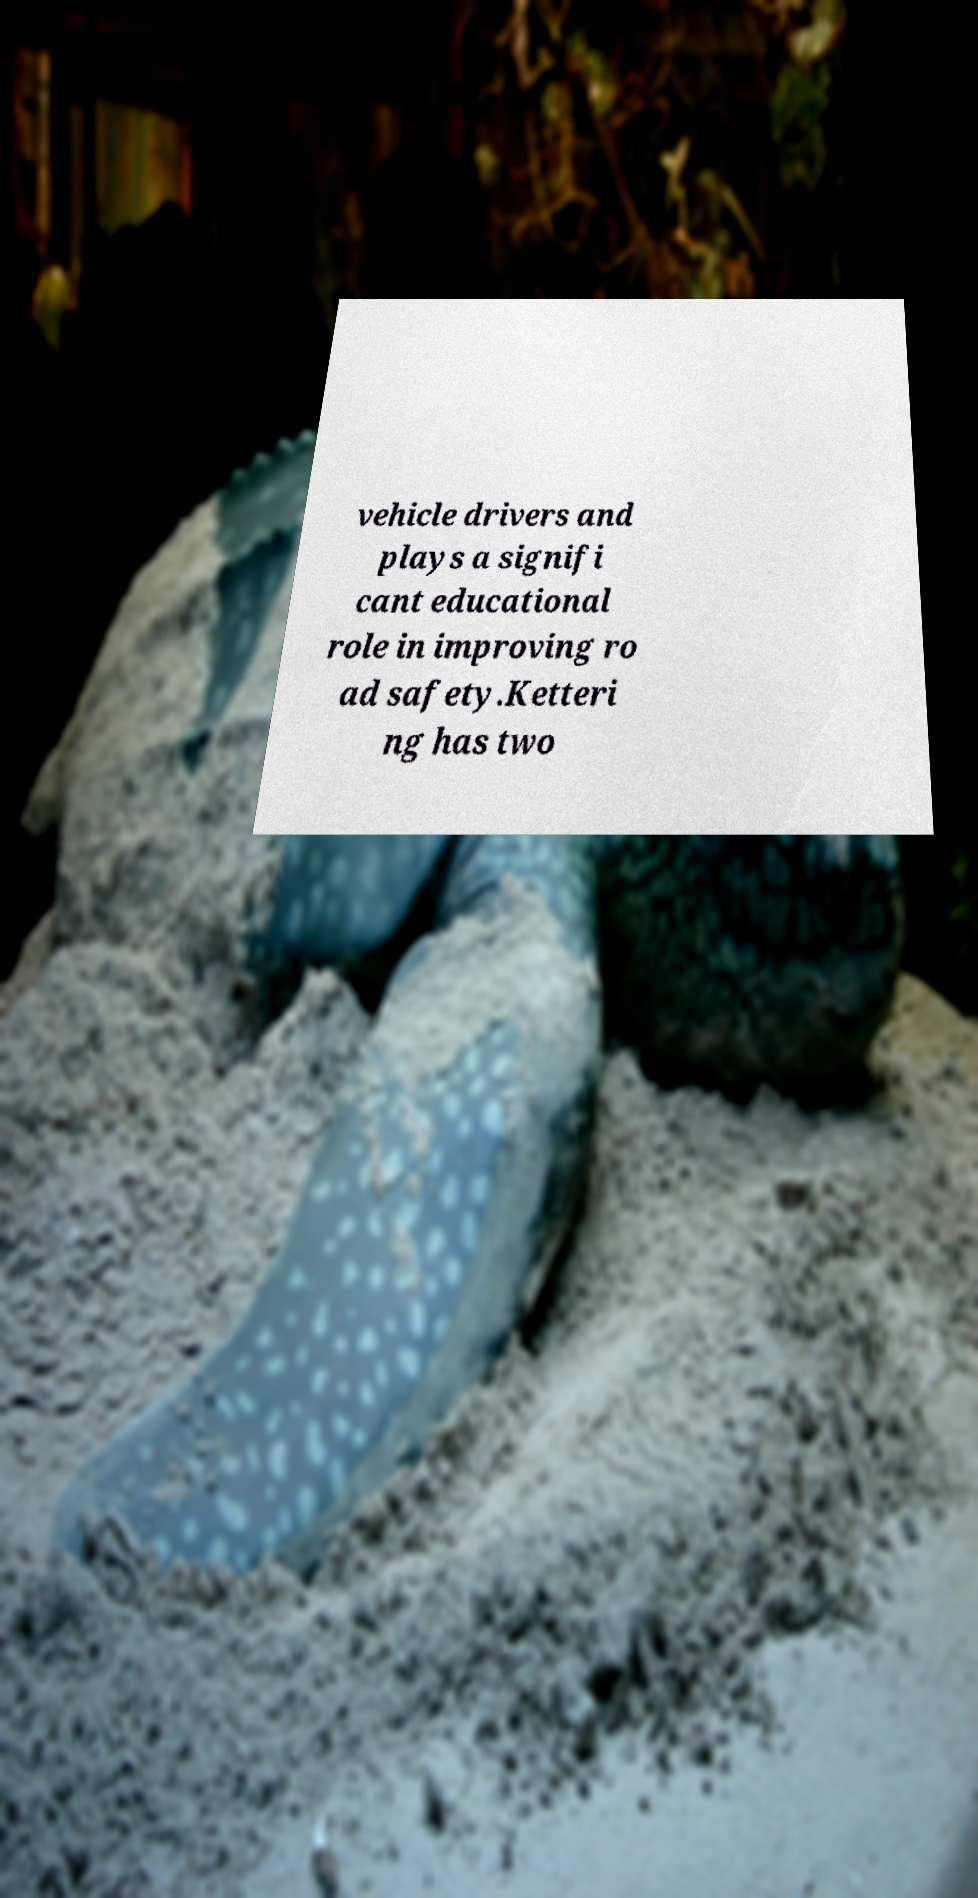Please identify and transcribe the text found in this image. vehicle drivers and plays a signifi cant educational role in improving ro ad safety.Ketteri ng has two 